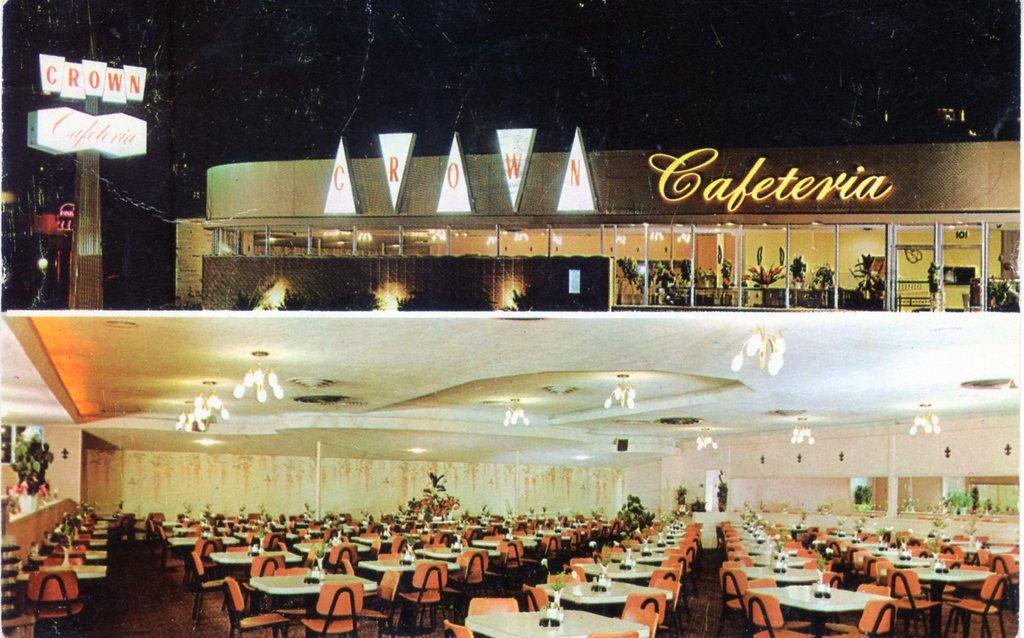What type of establishment is shown in the image? The image depicts a restaurant. How has the image been altered or modified? The image appears to be edited and made into a collage. What type of furniture is visible at the bottom of the image? There are chairs and tables at the bottom of the image. What part of the natural environment is visible in the image? The sky is visible at the top of the image. Can you see any bats flying in the night sky in the image? There are no bats or night sky visible in the image; it depicts a restaurant with a sky visible at the top. What type of furniture is present in the office setting in the image? There is no office setting or desk present in the image; it depicts a restaurant with chairs and tables. 